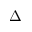Convert formula to latex. <formula><loc_0><loc_0><loc_500><loc_500>\Delta</formula> 